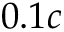Convert formula to latex. <formula><loc_0><loc_0><loc_500><loc_500>0 . 1 c</formula> 